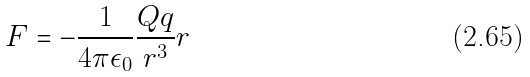Convert formula to latex. <formula><loc_0><loc_0><loc_500><loc_500>F = - \frac { 1 } { 4 \pi \epsilon _ { 0 } } \frac { Q q } { r ^ { 3 } } r</formula> 